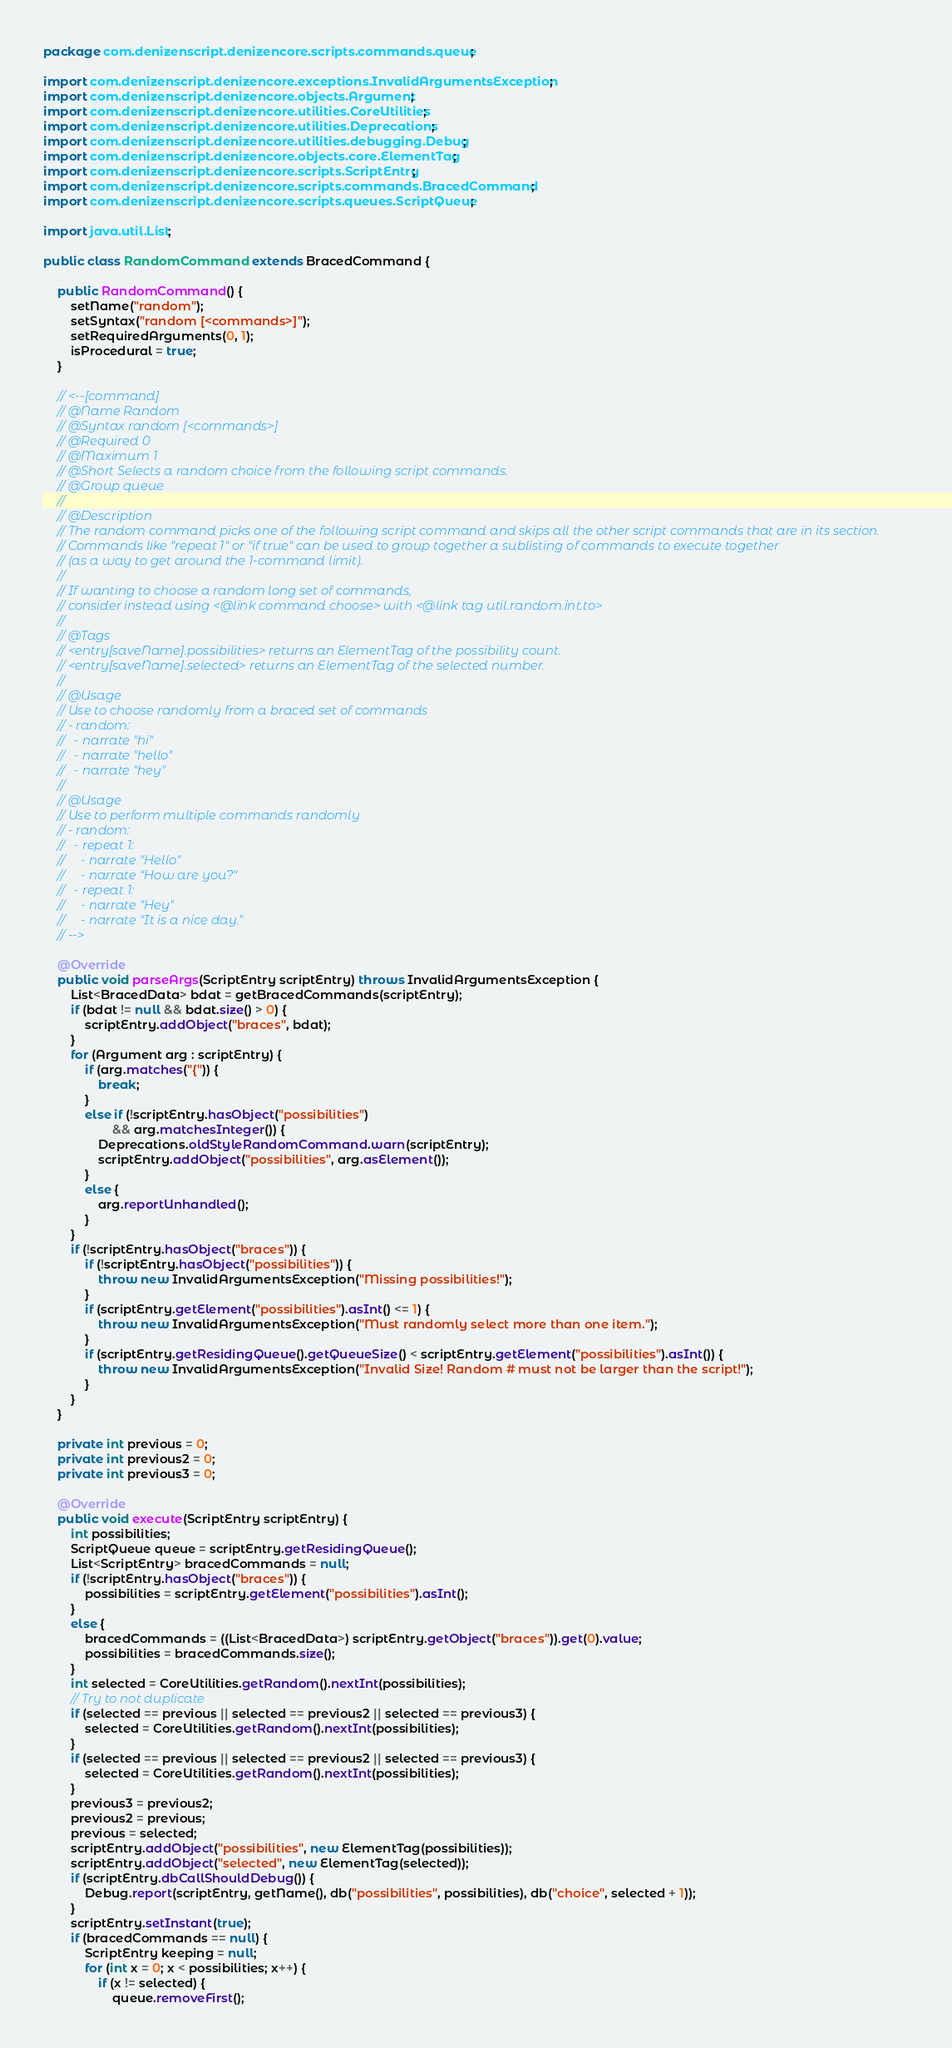<code> <loc_0><loc_0><loc_500><loc_500><_Java_>package com.denizenscript.denizencore.scripts.commands.queue;

import com.denizenscript.denizencore.exceptions.InvalidArgumentsException;
import com.denizenscript.denizencore.objects.Argument;
import com.denizenscript.denizencore.utilities.CoreUtilities;
import com.denizenscript.denizencore.utilities.Deprecations;
import com.denizenscript.denizencore.utilities.debugging.Debug;
import com.denizenscript.denizencore.objects.core.ElementTag;
import com.denizenscript.denizencore.scripts.ScriptEntry;
import com.denizenscript.denizencore.scripts.commands.BracedCommand;
import com.denizenscript.denizencore.scripts.queues.ScriptQueue;

import java.util.List;

public class RandomCommand extends BracedCommand {

    public RandomCommand() {
        setName("random");
        setSyntax("random [<commands>]");
        setRequiredArguments(0, 1);
        isProcedural = true;
    }

    // <--[command]
    // @Name Random
    // @Syntax random [<commands>]
    // @Required 0
    // @Maximum 1
    // @Short Selects a random choice from the following script commands.
    // @Group queue
    //
    // @Description
    // The random command picks one of the following script command and skips all the other script commands that are in its section.
    // Commands like "repeat 1" or "if true" can be used to group together a sublisting of commands to execute together
    // (as a way to get around the 1-command limit).
    //
    // If wanting to choose a random long set of commands,
    // consider instead using <@link command choose> with <@link tag util.random.int.to>
    //
    // @Tags
    // <entry[saveName].possibilities> returns an ElementTag of the possibility count.
    // <entry[saveName].selected> returns an ElementTag of the selected number.
    //
    // @Usage
    // Use to choose randomly from a braced set of commands
    // - random:
    //   - narrate "hi"
    //   - narrate "hello"
    //   - narrate "hey"
    //
    // @Usage
    // Use to perform multiple commands randomly
    // - random:
    //   - repeat 1:
    //     - narrate "Hello"
    //     - narrate "How are you?"
    //   - repeat 1:
    //     - narrate "Hey"
    //     - narrate "It is a nice day."
    // -->

    @Override
    public void parseArgs(ScriptEntry scriptEntry) throws InvalidArgumentsException {
        List<BracedData> bdat = getBracedCommands(scriptEntry);
        if (bdat != null && bdat.size() > 0) {
            scriptEntry.addObject("braces", bdat);
        }
        for (Argument arg : scriptEntry) {
            if (arg.matches("{")) {
                break;
            }
            else if (!scriptEntry.hasObject("possibilities")
                    && arg.matchesInteger()) {
                Deprecations.oldStyleRandomCommand.warn(scriptEntry);
                scriptEntry.addObject("possibilities", arg.asElement());
            }
            else {
                arg.reportUnhandled();
            }
        }
        if (!scriptEntry.hasObject("braces")) {
            if (!scriptEntry.hasObject("possibilities")) {
                throw new InvalidArgumentsException("Missing possibilities!");
            }
            if (scriptEntry.getElement("possibilities").asInt() <= 1) {
                throw new InvalidArgumentsException("Must randomly select more than one item.");
            }
            if (scriptEntry.getResidingQueue().getQueueSize() < scriptEntry.getElement("possibilities").asInt()) {
                throw new InvalidArgumentsException("Invalid Size! Random # must not be larger than the script!");
            }
        }
    }

    private int previous = 0;
    private int previous2 = 0;
    private int previous3 = 0;

    @Override
    public void execute(ScriptEntry scriptEntry) {
        int possibilities;
        ScriptQueue queue = scriptEntry.getResidingQueue();
        List<ScriptEntry> bracedCommands = null;
        if (!scriptEntry.hasObject("braces")) {
            possibilities = scriptEntry.getElement("possibilities").asInt();
        }
        else {
            bracedCommands = ((List<BracedData>) scriptEntry.getObject("braces")).get(0).value;
            possibilities = bracedCommands.size();
        }
        int selected = CoreUtilities.getRandom().nextInt(possibilities);
        // Try to not duplicate
        if (selected == previous || selected == previous2 || selected == previous3) {
            selected = CoreUtilities.getRandom().nextInt(possibilities);
        }
        if (selected == previous || selected == previous2 || selected == previous3) {
            selected = CoreUtilities.getRandom().nextInt(possibilities);
        }
        previous3 = previous2;
        previous2 = previous;
        previous = selected;
        scriptEntry.addObject("possibilities", new ElementTag(possibilities));
        scriptEntry.addObject("selected", new ElementTag(selected));
        if (scriptEntry.dbCallShouldDebug()) {
            Debug.report(scriptEntry, getName(), db("possibilities", possibilities), db("choice", selected + 1));
        }
        scriptEntry.setInstant(true);
        if (bracedCommands == null) {
            ScriptEntry keeping = null;
            for (int x = 0; x < possibilities; x++) {
                if (x != selected) {
                    queue.removeFirst();</code> 